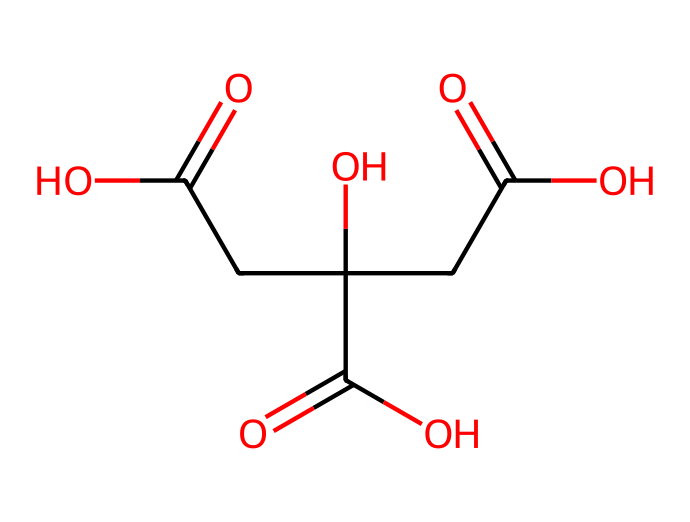How many carbon atoms are in citric acid? The SMILES representation shows a total of 6 carbon atoms in its structure (C). Each 'C' indicates a carbon atom.
Answer: 6 What is the molecular formula of citric acid? By analyzing the SMILES, we see it has 6 carbon (C), 8 hydrogen (H), and 7 oxygen (O) atoms, leading to the molecular formula C6H8O7.
Answer: C6H8O7 What type of functional groups are present in citric acid? The SMILES representation indicates carboxylic acids due to the presence of -COOH groups. This includes three carboxylic acid functional groups (indicated by C(=O)O).
Answer: carboxylic acid How many hydroxyl (-OH) groups are in citric acid? By counting the -OH groups associated with the carbon atoms in the structure, we determine that there are one hydroxyl group in citric acid. This can be seen where 'O' is attached to a carbon represented as C-C.
Answer: 1 Which aspect of citric acid contributes to its sour taste? The presence of carboxylic acid functional groups (-COOH) contributes to the sour taste. This can be seen in the structure as there are three -COOH groups present.
Answer: carboxylic acids What is the importance of citric acid in food preservation? Citric acid acts as a natural preservative by lowering the pH and inhibiting microbial growth. This is attributed to the multiple carboxylic acid groups in the structure, which lower the pH.
Answer: natural preservative How many oxygen atoms are present in citric acid? By decoding the SMILES, we can count a total of 7 oxygen atoms, indicated by the 'O' characters present in the structure.
Answer: 7 